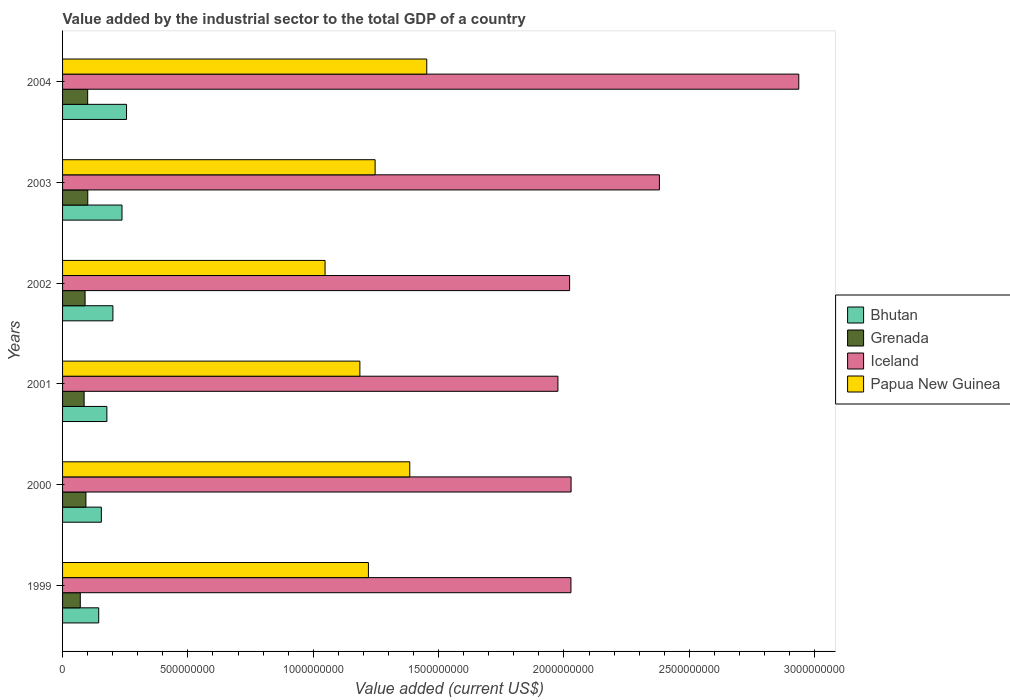How many different coloured bars are there?
Ensure brevity in your answer.  4. Are the number of bars per tick equal to the number of legend labels?
Your answer should be compact. Yes. How many bars are there on the 1st tick from the bottom?
Offer a terse response. 4. In how many cases, is the number of bars for a given year not equal to the number of legend labels?
Your answer should be compact. 0. What is the value added by the industrial sector to the total GDP in Papua New Guinea in 2000?
Keep it short and to the point. 1.38e+09. Across all years, what is the maximum value added by the industrial sector to the total GDP in Papua New Guinea?
Ensure brevity in your answer.  1.45e+09. Across all years, what is the minimum value added by the industrial sector to the total GDP in Iceland?
Provide a succinct answer. 1.98e+09. In which year was the value added by the industrial sector to the total GDP in Papua New Guinea minimum?
Offer a very short reply. 2002. What is the total value added by the industrial sector to the total GDP in Iceland in the graph?
Provide a short and direct response. 1.34e+1. What is the difference between the value added by the industrial sector to the total GDP in Grenada in 1999 and that in 2000?
Keep it short and to the point. -2.25e+07. What is the difference between the value added by the industrial sector to the total GDP in Grenada in 2004 and the value added by the industrial sector to the total GDP in Bhutan in 1999?
Make the answer very short. -4.41e+07. What is the average value added by the industrial sector to the total GDP in Grenada per year?
Provide a succinct answer. 9.00e+07. In the year 2000, what is the difference between the value added by the industrial sector to the total GDP in Grenada and value added by the industrial sector to the total GDP in Bhutan?
Offer a very short reply. -6.15e+07. What is the ratio of the value added by the industrial sector to the total GDP in Grenada in 1999 to that in 2001?
Ensure brevity in your answer.  0.82. Is the value added by the industrial sector to the total GDP in Papua New Guinea in 2001 less than that in 2004?
Keep it short and to the point. Yes. Is the difference between the value added by the industrial sector to the total GDP in Grenada in 2001 and 2003 greater than the difference between the value added by the industrial sector to the total GDP in Bhutan in 2001 and 2003?
Give a very brief answer. Yes. What is the difference between the highest and the second highest value added by the industrial sector to the total GDP in Grenada?
Your answer should be very brief. 4.01e+05. What is the difference between the highest and the lowest value added by the industrial sector to the total GDP in Grenada?
Your answer should be very brief. 2.99e+07. In how many years, is the value added by the industrial sector to the total GDP in Bhutan greater than the average value added by the industrial sector to the total GDP in Bhutan taken over all years?
Your answer should be very brief. 3. Is the sum of the value added by the industrial sector to the total GDP in Bhutan in 2001 and 2004 greater than the maximum value added by the industrial sector to the total GDP in Grenada across all years?
Provide a short and direct response. Yes. What does the 1st bar from the top in 2002 represents?
Your answer should be compact. Papua New Guinea. What does the 1st bar from the bottom in 2001 represents?
Give a very brief answer. Bhutan. How many bars are there?
Your response must be concise. 24. What is the difference between two consecutive major ticks on the X-axis?
Your response must be concise. 5.00e+08. Does the graph contain any zero values?
Provide a succinct answer. No. Where does the legend appear in the graph?
Your response must be concise. Center right. How many legend labels are there?
Offer a very short reply. 4. What is the title of the graph?
Your response must be concise. Value added by the industrial sector to the total GDP of a country. Does "Mauritania" appear as one of the legend labels in the graph?
Keep it short and to the point. No. What is the label or title of the X-axis?
Offer a terse response. Value added (current US$). What is the label or title of the Y-axis?
Keep it short and to the point. Years. What is the Value added (current US$) of Bhutan in 1999?
Keep it short and to the point. 1.44e+08. What is the Value added (current US$) of Grenada in 1999?
Offer a very short reply. 7.06e+07. What is the Value added (current US$) in Iceland in 1999?
Keep it short and to the point. 2.03e+09. What is the Value added (current US$) of Papua New Guinea in 1999?
Your answer should be very brief. 1.22e+09. What is the Value added (current US$) of Bhutan in 2000?
Your answer should be very brief. 1.55e+08. What is the Value added (current US$) of Grenada in 2000?
Your response must be concise. 9.31e+07. What is the Value added (current US$) in Iceland in 2000?
Give a very brief answer. 2.03e+09. What is the Value added (current US$) in Papua New Guinea in 2000?
Provide a short and direct response. 1.38e+09. What is the Value added (current US$) of Bhutan in 2001?
Your answer should be compact. 1.77e+08. What is the Value added (current US$) of Grenada in 2001?
Provide a succinct answer. 8.59e+07. What is the Value added (current US$) in Iceland in 2001?
Give a very brief answer. 1.98e+09. What is the Value added (current US$) in Papua New Guinea in 2001?
Your answer should be very brief. 1.19e+09. What is the Value added (current US$) of Bhutan in 2002?
Provide a succinct answer. 2.01e+08. What is the Value added (current US$) in Grenada in 2002?
Ensure brevity in your answer.  8.98e+07. What is the Value added (current US$) in Iceland in 2002?
Your response must be concise. 2.02e+09. What is the Value added (current US$) in Papua New Guinea in 2002?
Your answer should be compact. 1.05e+09. What is the Value added (current US$) in Bhutan in 2003?
Provide a short and direct response. 2.37e+08. What is the Value added (current US$) of Grenada in 2003?
Provide a succinct answer. 1.01e+08. What is the Value added (current US$) of Iceland in 2003?
Provide a short and direct response. 2.38e+09. What is the Value added (current US$) in Papua New Guinea in 2003?
Offer a terse response. 1.25e+09. What is the Value added (current US$) of Bhutan in 2004?
Provide a short and direct response. 2.55e+08. What is the Value added (current US$) in Grenada in 2004?
Your answer should be compact. 1.00e+08. What is the Value added (current US$) in Iceland in 2004?
Offer a very short reply. 2.94e+09. What is the Value added (current US$) in Papua New Guinea in 2004?
Your response must be concise. 1.45e+09. Across all years, what is the maximum Value added (current US$) in Bhutan?
Offer a very short reply. 2.55e+08. Across all years, what is the maximum Value added (current US$) in Grenada?
Your answer should be compact. 1.01e+08. Across all years, what is the maximum Value added (current US$) in Iceland?
Provide a succinct answer. 2.94e+09. Across all years, what is the maximum Value added (current US$) in Papua New Guinea?
Give a very brief answer. 1.45e+09. Across all years, what is the minimum Value added (current US$) in Bhutan?
Keep it short and to the point. 1.44e+08. Across all years, what is the minimum Value added (current US$) in Grenada?
Your answer should be very brief. 7.06e+07. Across all years, what is the minimum Value added (current US$) of Iceland?
Keep it short and to the point. 1.98e+09. Across all years, what is the minimum Value added (current US$) of Papua New Guinea?
Make the answer very short. 1.05e+09. What is the total Value added (current US$) in Bhutan in the graph?
Offer a terse response. 1.17e+09. What is the total Value added (current US$) in Grenada in the graph?
Provide a succinct answer. 5.40e+08. What is the total Value added (current US$) of Iceland in the graph?
Provide a short and direct response. 1.34e+1. What is the total Value added (current US$) in Papua New Guinea in the graph?
Ensure brevity in your answer.  7.54e+09. What is the difference between the Value added (current US$) of Bhutan in 1999 and that in 2000?
Your response must be concise. -1.04e+07. What is the difference between the Value added (current US$) in Grenada in 1999 and that in 2000?
Your answer should be compact. -2.25e+07. What is the difference between the Value added (current US$) in Iceland in 1999 and that in 2000?
Your response must be concise. -5.31e+05. What is the difference between the Value added (current US$) of Papua New Guinea in 1999 and that in 2000?
Your answer should be very brief. -1.65e+08. What is the difference between the Value added (current US$) of Bhutan in 1999 and that in 2001?
Give a very brief answer. -3.25e+07. What is the difference between the Value added (current US$) in Grenada in 1999 and that in 2001?
Your response must be concise. -1.53e+07. What is the difference between the Value added (current US$) of Iceland in 1999 and that in 2001?
Provide a short and direct response. 5.19e+07. What is the difference between the Value added (current US$) in Papua New Guinea in 1999 and that in 2001?
Keep it short and to the point. 3.41e+07. What is the difference between the Value added (current US$) of Bhutan in 1999 and that in 2002?
Your answer should be compact. -5.66e+07. What is the difference between the Value added (current US$) of Grenada in 1999 and that in 2002?
Offer a very short reply. -1.91e+07. What is the difference between the Value added (current US$) of Iceland in 1999 and that in 2002?
Give a very brief answer. 5.24e+06. What is the difference between the Value added (current US$) of Papua New Guinea in 1999 and that in 2002?
Your answer should be very brief. 1.73e+08. What is the difference between the Value added (current US$) of Bhutan in 1999 and that in 2003?
Your answer should be compact. -9.29e+07. What is the difference between the Value added (current US$) of Grenada in 1999 and that in 2003?
Your answer should be very brief. -2.99e+07. What is the difference between the Value added (current US$) of Iceland in 1999 and that in 2003?
Your response must be concise. -3.53e+08. What is the difference between the Value added (current US$) in Papua New Guinea in 1999 and that in 2003?
Keep it short and to the point. -2.67e+07. What is the difference between the Value added (current US$) of Bhutan in 1999 and that in 2004?
Ensure brevity in your answer.  -1.11e+08. What is the difference between the Value added (current US$) of Grenada in 1999 and that in 2004?
Ensure brevity in your answer.  -2.95e+07. What is the difference between the Value added (current US$) of Iceland in 1999 and that in 2004?
Ensure brevity in your answer.  -9.09e+08. What is the difference between the Value added (current US$) of Papua New Guinea in 1999 and that in 2004?
Keep it short and to the point. -2.33e+08. What is the difference between the Value added (current US$) of Bhutan in 2000 and that in 2001?
Provide a short and direct response. -2.21e+07. What is the difference between the Value added (current US$) of Grenada in 2000 and that in 2001?
Offer a terse response. 7.20e+06. What is the difference between the Value added (current US$) of Iceland in 2000 and that in 2001?
Your response must be concise. 5.24e+07. What is the difference between the Value added (current US$) of Papua New Guinea in 2000 and that in 2001?
Offer a terse response. 1.99e+08. What is the difference between the Value added (current US$) in Bhutan in 2000 and that in 2002?
Provide a short and direct response. -4.62e+07. What is the difference between the Value added (current US$) in Grenada in 2000 and that in 2002?
Provide a succinct answer. 3.35e+06. What is the difference between the Value added (current US$) of Iceland in 2000 and that in 2002?
Keep it short and to the point. 5.77e+06. What is the difference between the Value added (current US$) in Papua New Guinea in 2000 and that in 2002?
Offer a terse response. 3.38e+08. What is the difference between the Value added (current US$) in Bhutan in 2000 and that in 2003?
Provide a short and direct response. -8.24e+07. What is the difference between the Value added (current US$) in Grenada in 2000 and that in 2003?
Offer a very short reply. -7.39e+06. What is the difference between the Value added (current US$) of Iceland in 2000 and that in 2003?
Provide a short and direct response. -3.52e+08. What is the difference between the Value added (current US$) of Papua New Guinea in 2000 and that in 2003?
Offer a terse response. 1.38e+08. What is the difference between the Value added (current US$) in Bhutan in 2000 and that in 2004?
Your answer should be very brief. -1.00e+08. What is the difference between the Value added (current US$) in Grenada in 2000 and that in 2004?
Offer a very short reply. -6.99e+06. What is the difference between the Value added (current US$) of Iceland in 2000 and that in 2004?
Provide a succinct answer. -9.08e+08. What is the difference between the Value added (current US$) in Papua New Guinea in 2000 and that in 2004?
Your answer should be very brief. -6.78e+07. What is the difference between the Value added (current US$) in Bhutan in 2001 and that in 2002?
Your answer should be compact. -2.41e+07. What is the difference between the Value added (current US$) of Grenada in 2001 and that in 2002?
Provide a succinct answer. -3.85e+06. What is the difference between the Value added (current US$) in Iceland in 2001 and that in 2002?
Your answer should be very brief. -4.67e+07. What is the difference between the Value added (current US$) in Papua New Guinea in 2001 and that in 2002?
Keep it short and to the point. 1.39e+08. What is the difference between the Value added (current US$) of Bhutan in 2001 and that in 2003?
Make the answer very short. -6.04e+07. What is the difference between the Value added (current US$) of Grenada in 2001 and that in 2003?
Your response must be concise. -1.46e+07. What is the difference between the Value added (current US$) of Iceland in 2001 and that in 2003?
Your answer should be compact. -4.05e+08. What is the difference between the Value added (current US$) of Papua New Guinea in 2001 and that in 2003?
Give a very brief answer. -6.08e+07. What is the difference between the Value added (current US$) in Bhutan in 2001 and that in 2004?
Give a very brief answer. -7.84e+07. What is the difference between the Value added (current US$) in Grenada in 2001 and that in 2004?
Keep it short and to the point. -1.42e+07. What is the difference between the Value added (current US$) in Iceland in 2001 and that in 2004?
Offer a terse response. -9.61e+08. What is the difference between the Value added (current US$) in Papua New Guinea in 2001 and that in 2004?
Give a very brief answer. -2.67e+08. What is the difference between the Value added (current US$) of Bhutan in 2002 and that in 2003?
Provide a succinct answer. -3.63e+07. What is the difference between the Value added (current US$) in Grenada in 2002 and that in 2003?
Keep it short and to the point. -1.07e+07. What is the difference between the Value added (current US$) of Iceland in 2002 and that in 2003?
Offer a terse response. -3.58e+08. What is the difference between the Value added (current US$) in Papua New Guinea in 2002 and that in 2003?
Provide a succinct answer. -2.00e+08. What is the difference between the Value added (current US$) of Bhutan in 2002 and that in 2004?
Provide a short and direct response. -5.43e+07. What is the difference between the Value added (current US$) in Grenada in 2002 and that in 2004?
Provide a succinct answer. -1.03e+07. What is the difference between the Value added (current US$) in Iceland in 2002 and that in 2004?
Make the answer very short. -9.14e+08. What is the difference between the Value added (current US$) of Papua New Guinea in 2002 and that in 2004?
Offer a terse response. -4.06e+08. What is the difference between the Value added (current US$) in Bhutan in 2003 and that in 2004?
Provide a succinct answer. -1.80e+07. What is the difference between the Value added (current US$) in Grenada in 2003 and that in 2004?
Ensure brevity in your answer.  4.01e+05. What is the difference between the Value added (current US$) of Iceland in 2003 and that in 2004?
Your response must be concise. -5.56e+08. What is the difference between the Value added (current US$) of Papua New Guinea in 2003 and that in 2004?
Offer a terse response. -2.06e+08. What is the difference between the Value added (current US$) in Bhutan in 1999 and the Value added (current US$) in Grenada in 2000?
Offer a terse response. 5.11e+07. What is the difference between the Value added (current US$) in Bhutan in 1999 and the Value added (current US$) in Iceland in 2000?
Your answer should be very brief. -1.88e+09. What is the difference between the Value added (current US$) of Bhutan in 1999 and the Value added (current US$) of Papua New Guinea in 2000?
Make the answer very short. -1.24e+09. What is the difference between the Value added (current US$) of Grenada in 1999 and the Value added (current US$) of Iceland in 2000?
Your response must be concise. -1.96e+09. What is the difference between the Value added (current US$) in Grenada in 1999 and the Value added (current US$) in Papua New Guinea in 2000?
Provide a succinct answer. -1.31e+09. What is the difference between the Value added (current US$) in Iceland in 1999 and the Value added (current US$) in Papua New Guinea in 2000?
Make the answer very short. 6.43e+08. What is the difference between the Value added (current US$) of Bhutan in 1999 and the Value added (current US$) of Grenada in 2001?
Your answer should be compact. 5.83e+07. What is the difference between the Value added (current US$) of Bhutan in 1999 and the Value added (current US$) of Iceland in 2001?
Offer a very short reply. -1.83e+09. What is the difference between the Value added (current US$) in Bhutan in 1999 and the Value added (current US$) in Papua New Guinea in 2001?
Offer a very short reply. -1.04e+09. What is the difference between the Value added (current US$) in Grenada in 1999 and the Value added (current US$) in Iceland in 2001?
Provide a succinct answer. -1.91e+09. What is the difference between the Value added (current US$) of Grenada in 1999 and the Value added (current US$) of Papua New Guinea in 2001?
Give a very brief answer. -1.12e+09. What is the difference between the Value added (current US$) of Iceland in 1999 and the Value added (current US$) of Papua New Guinea in 2001?
Keep it short and to the point. 8.42e+08. What is the difference between the Value added (current US$) in Bhutan in 1999 and the Value added (current US$) in Grenada in 2002?
Give a very brief answer. 5.44e+07. What is the difference between the Value added (current US$) of Bhutan in 1999 and the Value added (current US$) of Iceland in 2002?
Provide a short and direct response. -1.88e+09. What is the difference between the Value added (current US$) in Bhutan in 1999 and the Value added (current US$) in Papua New Guinea in 2002?
Keep it short and to the point. -9.03e+08. What is the difference between the Value added (current US$) in Grenada in 1999 and the Value added (current US$) in Iceland in 2002?
Provide a succinct answer. -1.95e+09. What is the difference between the Value added (current US$) in Grenada in 1999 and the Value added (current US$) in Papua New Guinea in 2002?
Offer a very short reply. -9.76e+08. What is the difference between the Value added (current US$) in Iceland in 1999 and the Value added (current US$) in Papua New Guinea in 2002?
Offer a terse response. 9.81e+08. What is the difference between the Value added (current US$) in Bhutan in 1999 and the Value added (current US$) in Grenada in 2003?
Offer a very short reply. 4.37e+07. What is the difference between the Value added (current US$) in Bhutan in 1999 and the Value added (current US$) in Iceland in 2003?
Provide a succinct answer. -2.24e+09. What is the difference between the Value added (current US$) of Bhutan in 1999 and the Value added (current US$) of Papua New Guinea in 2003?
Make the answer very short. -1.10e+09. What is the difference between the Value added (current US$) of Grenada in 1999 and the Value added (current US$) of Iceland in 2003?
Ensure brevity in your answer.  -2.31e+09. What is the difference between the Value added (current US$) in Grenada in 1999 and the Value added (current US$) in Papua New Guinea in 2003?
Provide a succinct answer. -1.18e+09. What is the difference between the Value added (current US$) of Iceland in 1999 and the Value added (current US$) of Papua New Guinea in 2003?
Make the answer very short. 7.81e+08. What is the difference between the Value added (current US$) in Bhutan in 1999 and the Value added (current US$) in Grenada in 2004?
Your response must be concise. 4.41e+07. What is the difference between the Value added (current US$) in Bhutan in 1999 and the Value added (current US$) in Iceland in 2004?
Keep it short and to the point. -2.79e+09. What is the difference between the Value added (current US$) of Bhutan in 1999 and the Value added (current US$) of Papua New Guinea in 2004?
Offer a terse response. -1.31e+09. What is the difference between the Value added (current US$) of Grenada in 1999 and the Value added (current US$) of Iceland in 2004?
Ensure brevity in your answer.  -2.87e+09. What is the difference between the Value added (current US$) of Grenada in 1999 and the Value added (current US$) of Papua New Guinea in 2004?
Your response must be concise. -1.38e+09. What is the difference between the Value added (current US$) of Iceland in 1999 and the Value added (current US$) of Papua New Guinea in 2004?
Offer a very short reply. 5.75e+08. What is the difference between the Value added (current US$) of Bhutan in 2000 and the Value added (current US$) of Grenada in 2001?
Your answer should be very brief. 6.87e+07. What is the difference between the Value added (current US$) in Bhutan in 2000 and the Value added (current US$) in Iceland in 2001?
Provide a succinct answer. -1.82e+09. What is the difference between the Value added (current US$) of Bhutan in 2000 and the Value added (current US$) of Papua New Guinea in 2001?
Your answer should be very brief. -1.03e+09. What is the difference between the Value added (current US$) in Grenada in 2000 and the Value added (current US$) in Iceland in 2001?
Offer a very short reply. -1.88e+09. What is the difference between the Value added (current US$) in Grenada in 2000 and the Value added (current US$) in Papua New Guinea in 2001?
Your answer should be compact. -1.09e+09. What is the difference between the Value added (current US$) in Iceland in 2000 and the Value added (current US$) in Papua New Guinea in 2001?
Your answer should be very brief. 8.42e+08. What is the difference between the Value added (current US$) in Bhutan in 2000 and the Value added (current US$) in Grenada in 2002?
Make the answer very short. 6.49e+07. What is the difference between the Value added (current US$) in Bhutan in 2000 and the Value added (current US$) in Iceland in 2002?
Offer a terse response. -1.87e+09. What is the difference between the Value added (current US$) of Bhutan in 2000 and the Value added (current US$) of Papua New Guinea in 2002?
Give a very brief answer. -8.92e+08. What is the difference between the Value added (current US$) in Grenada in 2000 and the Value added (current US$) in Iceland in 2002?
Your response must be concise. -1.93e+09. What is the difference between the Value added (current US$) of Grenada in 2000 and the Value added (current US$) of Papua New Guinea in 2002?
Provide a short and direct response. -9.54e+08. What is the difference between the Value added (current US$) in Iceland in 2000 and the Value added (current US$) in Papua New Guinea in 2002?
Your answer should be compact. 9.81e+08. What is the difference between the Value added (current US$) of Bhutan in 2000 and the Value added (current US$) of Grenada in 2003?
Your response must be concise. 5.41e+07. What is the difference between the Value added (current US$) of Bhutan in 2000 and the Value added (current US$) of Iceland in 2003?
Make the answer very short. -2.23e+09. What is the difference between the Value added (current US$) of Bhutan in 2000 and the Value added (current US$) of Papua New Guinea in 2003?
Provide a short and direct response. -1.09e+09. What is the difference between the Value added (current US$) in Grenada in 2000 and the Value added (current US$) in Iceland in 2003?
Offer a very short reply. -2.29e+09. What is the difference between the Value added (current US$) in Grenada in 2000 and the Value added (current US$) in Papua New Guinea in 2003?
Keep it short and to the point. -1.15e+09. What is the difference between the Value added (current US$) in Iceland in 2000 and the Value added (current US$) in Papua New Guinea in 2003?
Your answer should be compact. 7.82e+08. What is the difference between the Value added (current US$) of Bhutan in 2000 and the Value added (current US$) of Grenada in 2004?
Give a very brief answer. 5.45e+07. What is the difference between the Value added (current US$) in Bhutan in 2000 and the Value added (current US$) in Iceland in 2004?
Keep it short and to the point. -2.78e+09. What is the difference between the Value added (current US$) in Bhutan in 2000 and the Value added (current US$) in Papua New Guinea in 2004?
Ensure brevity in your answer.  -1.30e+09. What is the difference between the Value added (current US$) in Grenada in 2000 and the Value added (current US$) in Iceland in 2004?
Provide a succinct answer. -2.84e+09. What is the difference between the Value added (current US$) of Grenada in 2000 and the Value added (current US$) of Papua New Guinea in 2004?
Your answer should be very brief. -1.36e+09. What is the difference between the Value added (current US$) of Iceland in 2000 and the Value added (current US$) of Papua New Guinea in 2004?
Your answer should be compact. 5.76e+08. What is the difference between the Value added (current US$) of Bhutan in 2001 and the Value added (current US$) of Grenada in 2002?
Give a very brief answer. 8.69e+07. What is the difference between the Value added (current US$) of Bhutan in 2001 and the Value added (current US$) of Iceland in 2002?
Keep it short and to the point. -1.85e+09. What is the difference between the Value added (current US$) of Bhutan in 2001 and the Value added (current US$) of Papua New Guinea in 2002?
Your answer should be compact. -8.70e+08. What is the difference between the Value added (current US$) in Grenada in 2001 and the Value added (current US$) in Iceland in 2002?
Offer a very short reply. -1.94e+09. What is the difference between the Value added (current US$) of Grenada in 2001 and the Value added (current US$) of Papua New Guinea in 2002?
Give a very brief answer. -9.61e+08. What is the difference between the Value added (current US$) in Iceland in 2001 and the Value added (current US$) in Papua New Guinea in 2002?
Provide a succinct answer. 9.29e+08. What is the difference between the Value added (current US$) of Bhutan in 2001 and the Value added (current US$) of Grenada in 2003?
Provide a short and direct response. 7.62e+07. What is the difference between the Value added (current US$) of Bhutan in 2001 and the Value added (current US$) of Iceland in 2003?
Provide a succinct answer. -2.20e+09. What is the difference between the Value added (current US$) of Bhutan in 2001 and the Value added (current US$) of Papua New Guinea in 2003?
Offer a terse response. -1.07e+09. What is the difference between the Value added (current US$) of Grenada in 2001 and the Value added (current US$) of Iceland in 2003?
Your answer should be very brief. -2.29e+09. What is the difference between the Value added (current US$) of Grenada in 2001 and the Value added (current US$) of Papua New Guinea in 2003?
Make the answer very short. -1.16e+09. What is the difference between the Value added (current US$) of Iceland in 2001 and the Value added (current US$) of Papua New Guinea in 2003?
Provide a succinct answer. 7.29e+08. What is the difference between the Value added (current US$) in Bhutan in 2001 and the Value added (current US$) in Grenada in 2004?
Keep it short and to the point. 7.66e+07. What is the difference between the Value added (current US$) in Bhutan in 2001 and the Value added (current US$) in Iceland in 2004?
Offer a very short reply. -2.76e+09. What is the difference between the Value added (current US$) of Bhutan in 2001 and the Value added (current US$) of Papua New Guinea in 2004?
Offer a very short reply. -1.28e+09. What is the difference between the Value added (current US$) in Grenada in 2001 and the Value added (current US$) in Iceland in 2004?
Keep it short and to the point. -2.85e+09. What is the difference between the Value added (current US$) in Grenada in 2001 and the Value added (current US$) in Papua New Guinea in 2004?
Your response must be concise. -1.37e+09. What is the difference between the Value added (current US$) of Iceland in 2001 and the Value added (current US$) of Papua New Guinea in 2004?
Offer a very short reply. 5.23e+08. What is the difference between the Value added (current US$) of Bhutan in 2002 and the Value added (current US$) of Grenada in 2003?
Provide a succinct answer. 1.00e+08. What is the difference between the Value added (current US$) of Bhutan in 2002 and the Value added (current US$) of Iceland in 2003?
Provide a short and direct response. -2.18e+09. What is the difference between the Value added (current US$) in Bhutan in 2002 and the Value added (current US$) in Papua New Guinea in 2003?
Ensure brevity in your answer.  -1.05e+09. What is the difference between the Value added (current US$) in Grenada in 2002 and the Value added (current US$) in Iceland in 2003?
Provide a short and direct response. -2.29e+09. What is the difference between the Value added (current US$) of Grenada in 2002 and the Value added (current US$) of Papua New Guinea in 2003?
Offer a terse response. -1.16e+09. What is the difference between the Value added (current US$) in Iceland in 2002 and the Value added (current US$) in Papua New Guinea in 2003?
Give a very brief answer. 7.76e+08. What is the difference between the Value added (current US$) of Bhutan in 2002 and the Value added (current US$) of Grenada in 2004?
Your answer should be compact. 1.01e+08. What is the difference between the Value added (current US$) of Bhutan in 2002 and the Value added (current US$) of Iceland in 2004?
Your response must be concise. -2.74e+09. What is the difference between the Value added (current US$) in Bhutan in 2002 and the Value added (current US$) in Papua New Guinea in 2004?
Ensure brevity in your answer.  -1.25e+09. What is the difference between the Value added (current US$) in Grenada in 2002 and the Value added (current US$) in Iceland in 2004?
Your answer should be very brief. -2.85e+09. What is the difference between the Value added (current US$) of Grenada in 2002 and the Value added (current US$) of Papua New Guinea in 2004?
Keep it short and to the point. -1.36e+09. What is the difference between the Value added (current US$) in Iceland in 2002 and the Value added (current US$) in Papua New Guinea in 2004?
Offer a very short reply. 5.70e+08. What is the difference between the Value added (current US$) in Bhutan in 2003 and the Value added (current US$) in Grenada in 2004?
Your answer should be compact. 1.37e+08. What is the difference between the Value added (current US$) in Bhutan in 2003 and the Value added (current US$) in Iceland in 2004?
Offer a terse response. -2.70e+09. What is the difference between the Value added (current US$) of Bhutan in 2003 and the Value added (current US$) of Papua New Guinea in 2004?
Provide a succinct answer. -1.22e+09. What is the difference between the Value added (current US$) of Grenada in 2003 and the Value added (current US$) of Iceland in 2004?
Your response must be concise. -2.84e+09. What is the difference between the Value added (current US$) of Grenada in 2003 and the Value added (current US$) of Papua New Guinea in 2004?
Your answer should be compact. -1.35e+09. What is the difference between the Value added (current US$) in Iceland in 2003 and the Value added (current US$) in Papua New Guinea in 2004?
Ensure brevity in your answer.  9.28e+08. What is the average Value added (current US$) of Bhutan per year?
Your response must be concise. 1.95e+08. What is the average Value added (current US$) of Grenada per year?
Make the answer very short. 9.00e+07. What is the average Value added (current US$) of Iceland per year?
Your answer should be compact. 2.23e+09. What is the average Value added (current US$) in Papua New Guinea per year?
Make the answer very short. 1.26e+09. In the year 1999, what is the difference between the Value added (current US$) of Bhutan and Value added (current US$) of Grenada?
Your answer should be very brief. 7.36e+07. In the year 1999, what is the difference between the Value added (current US$) in Bhutan and Value added (current US$) in Iceland?
Keep it short and to the point. -1.88e+09. In the year 1999, what is the difference between the Value added (current US$) of Bhutan and Value added (current US$) of Papua New Guinea?
Provide a succinct answer. -1.08e+09. In the year 1999, what is the difference between the Value added (current US$) in Grenada and Value added (current US$) in Iceland?
Give a very brief answer. -1.96e+09. In the year 1999, what is the difference between the Value added (current US$) of Grenada and Value added (current US$) of Papua New Guinea?
Provide a short and direct response. -1.15e+09. In the year 1999, what is the difference between the Value added (current US$) of Iceland and Value added (current US$) of Papua New Guinea?
Provide a short and direct response. 8.08e+08. In the year 2000, what is the difference between the Value added (current US$) in Bhutan and Value added (current US$) in Grenada?
Ensure brevity in your answer.  6.15e+07. In the year 2000, what is the difference between the Value added (current US$) of Bhutan and Value added (current US$) of Iceland?
Your response must be concise. -1.87e+09. In the year 2000, what is the difference between the Value added (current US$) in Bhutan and Value added (current US$) in Papua New Guinea?
Give a very brief answer. -1.23e+09. In the year 2000, what is the difference between the Value added (current US$) of Grenada and Value added (current US$) of Iceland?
Offer a terse response. -1.94e+09. In the year 2000, what is the difference between the Value added (current US$) of Grenada and Value added (current US$) of Papua New Guinea?
Offer a very short reply. -1.29e+09. In the year 2000, what is the difference between the Value added (current US$) of Iceland and Value added (current US$) of Papua New Guinea?
Make the answer very short. 6.43e+08. In the year 2001, what is the difference between the Value added (current US$) of Bhutan and Value added (current US$) of Grenada?
Your answer should be very brief. 9.08e+07. In the year 2001, what is the difference between the Value added (current US$) of Bhutan and Value added (current US$) of Iceland?
Offer a terse response. -1.80e+09. In the year 2001, what is the difference between the Value added (current US$) in Bhutan and Value added (current US$) in Papua New Guinea?
Offer a very short reply. -1.01e+09. In the year 2001, what is the difference between the Value added (current US$) in Grenada and Value added (current US$) in Iceland?
Keep it short and to the point. -1.89e+09. In the year 2001, what is the difference between the Value added (current US$) in Grenada and Value added (current US$) in Papua New Guinea?
Provide a short and direct response. -1.10e+09. In the year 2001, what is the difference between the Value added (current US$) of Iceland and Value added (current US$) of Papua New Guinea?
Your response must be concise. 7.90e+08. In the year 2002, what is the difference between the Value added (current US$) of Bhutan and Value added (current US$) of Grenada?
Offer a very short reply. 1.11e+08. In the year 2002, what is the difference between the Value added (current US$) in Bhutan and Value added (current US$) in Iceland?
Give a very brief answer. -1.82e+09. In the year 2002, what is the difference between the Value added (current US$) in Bhutan and Value added (current US$) in Papua New Guinea?
Provide a short and direct response. -8.46e+08. In the year 2002, what is the difference between the Value added (current US$) in Grenada and Value added (current US$) in Iceland?
Provide a short and direct response. -1.93e+09. In the year 2002, what is the difference between the Value added (current US$) in Grenada and Value added (current US$) in Papua New Guinea?
Provide a short and direct response. -9.57e+08. In the year 2002, what is the difference between the Value added (current US$) of Iceland and Value added (current US$) of Papua New Guinea?
Give a very brief answer. 9.76e+08. In the year 2003, what is the difference between the Value added (current US$) of Bhutan and Value added (current US$) of Grenada?
Offer a terse response. 1.37e+08. In the year 2003, what is the difference between the Value added (current US$) of Bhutan and Value added (current US$) of Iceland?
Your answer should be very brief. -2.14e+09. In the year 2003, what is the difference between the Value added (current US$) of Bhutan and Value added (current US$) of Papua New Guinea?
Provide a short and direct response. -1.01e+09. In the year 2003, what is the difference between the Value added (current US$) in Grenada and Value added (current US$) in Iceland?
Your answer should be compact. -2.28e+09. In the year 2003, what is the difference between the Value added (current US$) of Grenada and Value added (current US$) of Papua New Guinea?
Your response must be concise. -1.15e+09. In the year 2003, what is the difference between the Value added (current US$) in Iceland and Value added (current US$) in Papua New Guinea?
Provide a short and direct response. 1.13e+09. In the year 2004, what is the difference between the Value added (current US$) of Bhutan and Value added (current US$) of Grenada?
Your answer should be compact. 1.55e+08. In the year 2004, what is the difference between the Value added (current US$) in Bhutan and Value added (current US$) in Iceland?
Offer a very short reply. -2.68e+09. In the year 2004, what is the difference between the Value added (current US$) in Bhutan and Value added (current US$) in Papua New Guinea?
Your response must be concise. -1.20e+09. In the year 2004, what is the difference between the Value added (current US$) of Grenada and Value added (current US$) of Iceland?
Keep it short and to the point. -2.84e+09. In the year 2004, what is the difference between the Value added (current US$) of Grenada and Value added (current US$) of Papua New Guinea?
Ensure brevity in your answer.  -1.35e+09. In the year 2004, what is the difference between the Value added (current US$) in Iceland and Value added (current US$) in Papua New Guinea?
Your answer should be compact. 1.48e+09. What is the ratio of the Value added (current US$) of Bhutan in 1999 to that in 2000?
Give a very brief answer. 0.93. What is the ratio of the Value added (current US$) of Grenada in 1999 to that in 2000?
Keep it short and to the point. 0.76. What is the ratio of the Value added (current US$) in Iceland in 1999 to that in 2000?
Ensure brevity in your answer.  1. What is the ratio of the Value added (current US$) of Papua New Guinea in 1999 to that in 2000?
Your response must be concise. 0.88. What is the ratio of the Value added (current US$) of Bhutan in 1999 to that in 2001?
Provide a succinct answer. 0.82. What is the ratio of the Value added (current US$) in Grenada in 1999 to that in 2001?
Make the answer very short. 0.82. What is the ratio of the Value added (current US$) in Iceland in 1999 to that in 2001?
Offer a very short reply. 1.03. What is the ratio of the Value added (current US$) in Papua New Guinea in 1999 to that in 2001?
Keep it short and to the point. 1.03. What is the ratio of the Value added (current US$) in Bhutan in 1999 to that in 2002?
Make the answer very short. 0.72. What is the ratio of the Value added (current US$) in Grenada in 1999 to that in 2002?
Your answer should be compact. 0.79. What is the ratio of the Value added (current US$) of Papua New Guinea in 1999 to that in 2002?
Offer a very short reply. 1.17. What is the ratio of the Value added (current US$) in Bhutan in 1999 to that in 2003?
Ensure brevity in your answer.  0.61. What is the ratio of the Value added (current US$) of Grenada in 1999 to that in 2003?
Offer a terse response. 0.7. What is the ratio of the Value added (current US$) of Iceland in 1999 to that in 2003?
Your answer should be very brief. 0.85. What is the ratio of the Value added (current US$) of Papua New Guinea in 1999 to that in 2003?
Offer a terse response. 0.98. What is the ratio of the Value added (current US$) of Bhutan in 1999 to that in 2004?
Make the answer very short. 0.57. What is the ratio of the Value added (current US$) of Grenada in 1999 to that in 2004?
Provide a succinct answer. 0.71. What is the ratio of the Value added (current US$) in Iceland in 1999 to that in 2004?
Provide a succinct answer. 0.69. What is the ratio of the Value added (current US$) in Papua New Guinea in 1999 to that in 2004?
Offer a terse response. 0.84. What is the ratio of the Value added (current US$) of Bhutan in 2000 to that in 2001?
Ensure brevity in your answer.  0.88. What is the ratio of the Value added (current US$) in Grenada in 2000 to that in 2001?
Your answer should be very brief. 1.08. What is the ratio of the Value added (current US$) in Iceland in 2000 to that in 2001?
Offer a terse response. 1.03. What is the ratio of the Value added (current US$) of Papua New Guinea in 2000 to that in 2001?
Your answer should be very brief. 1.17. What is the ratio of the Value added (current US$) of Bhutan in 2000 to that in 2002?
Offer a terse response. 0.77. What is the ratio of the Value added (current US$) of Grenada in 2000 to that in 2002?
Make the answer very short. 1.04. What is the ratio of the Value added (current US$) of Iceland in 2000 to that in 2002?
Offer a terse response. 1. What is the ratio of the Value added (current US$) in Papua New Guinea in 2000 to that in 2002?
Offer a terse response. 1.32. What is the ratio of the Value added (current US$) in Bhutan in 2000 to that in 2003?
Provide a short and direct response. 0.65. What is the ratio of the Value added (current US$) of Grenada in 2000 to that in 2003?
Your answer should be compact. 0.93. What is the ratio of the Value added (current US$) in Iceland in 2000 to that in 2003?
Your response must be concise. 0.85. What is the ratio of the Value added (current US$) in Papua New Guinea in 2000 to that in 2003?
Keep it short and to the point. 1.11. What is the ratio of the Value added (current US$) of Bhutan in 2000 to that in 2004?
Your answer should be very brief. 0.61. What is the ratio of the Value added (current US$) in Grenada in 2000 to that in 2004?
Your answer should be very brief. 0.93. What is the ratio of the Value added (current US$) of Iceland in 2000 to that in 2004?
Your answer should be very brief. 0.69. What is the ratio of the Value added (current US$) in Papua New Guinea in 2000 to that in 2004?
Your response must be concise. 0.95. What is the ratio of the Value added (current US$) of Bhutan in 2001 to that in 2002?
Your answer should be very brief. 0.88. What is the ratio of the Value added (current US$) in Grenada in 2001 to that in 2002?
Keep it short and to the point. 0.96. What is the ratio of the Value added (current US$) in Iceland in 2001 to that in 2002?
Give a very brief answer. 0.98. What is the ratio of the Value added (current US$) in Papua New Guinea in 2001 to that in 2002?
Provide a succinct answer. 1.13. What is the ratio of the Value added (current US$) of Bhutan in 2001 to that in 2003?
Provide a succinct answer. 0.75. What is the ratio of the Value added (current US$) of Grenada in 2001 to that in 2003?
Offer a very short reply. 0.85. What is the ratio of the Value added (current US$) of Iceland in 2001 to that in 2003?
Your answer should be very brief. 0.83. What is the ratio of the Value added (current US$) in Papua New Guinea in 2001 to that in 2003?
Provide a short and direct response. 0.95. What is the ratio of the Value added (current US$) in Bhutan in 2001 to that in 2004?
Make the answer very short. 0.69. What is the ratio of the Value added (current US$) of Grenada in 2001 to that in 2004?
Your answer should be very brief. 0.86. What is the ratio of the Value added (current US$) in Iceland in 2001 to that in 2004?
Give a very brief answer. 0.67. What is the ratio of the Value added (current US$) of Papua New Guinea in 2001 to that in 2004?
Your answer should be very brief. 0.82. What is the ratio of the Value added (current US$) of Bhutan in 2002 to that in 2003?
Offer a very short reply. 0.85. What is the ratio of the Value added (current US$) in Grenada in 2002 to that in 2003?
Keep it short and to the point. 0.89. What is the ratio of the Value added (current US$) of Iceland in 2002 to that in 2003?
Provide a succinct answer. 0.85. What is the ratio of the Value added (current US$) of Papua New Guinea in 2002 to that in 2003?
Provide a short and direct response. 0.84. What is the ratio of the Value added (current US$) in Bhutan in 2002 to that in 2004?
Offer a terse response. 0.79. What is the ratio of the Value added (current US$) of Grenada in 2002 to that in 2004?
Your response must be concise. 0.9. What is the ratio of the Value added (current US$) in Iceland in 2002 to that in 2004?
Your response must be concise. 0.69. What is the ratio of the Value added (current US$) of Papua New Guinea in 2002 to that in 2004?
Provide a succinct answer. 0.72. What is the ratio of the Value added (current US$) in Bhutan in 2003 to that in 2004?
Your response must be concise. 0.93. What is the ratio of the Value added (current US$) of Grenada in 2003 to that in 2004?
Your answer should be compact. 1. What is the ratio of the Value added (current US$) of Iceland in 2003 to that in 2004?
Ensure brevity in your answer.  0.81. What is the ratio of the Value added (current US$) of Papua New Guinea in 2003 to that in 2004?
Keep it short and to the point. 0.86. What is the difference between the highest and the second highest Value added (current US$) of Bhutan?
Make the answer very short. 1.80e+07. What is the difference between the highest and the second highest Value added (current US$) in Grenada?
Your answer should be compact. 4.01e+05. What is the difference between the highest and the second highest Value added (current US$) in Iceland?
Keep it short and to the point. 5.56e+08. What is the difference between the highest and the second highest Value added (current US$) in Papua New Guinea?
Your response must be concise. 6.78e+07. What is the difference between the highest and the lowest Value added (current US$) in Bhutan?
Provide a short and direct response. 1.11e+08. What is the difference between the highest and the lowest Value added (current US$) of Grenada?
Give a very brief answer. 2.99e+07. What is the difference between the highest and the lowest Value added (current US$) in Iceland?
Provide a succinct answer. 9.61e+08. What is the difference between the highest and the lowest Value added (current US$) in Papua New Guinea?
Your response must be concise. 4.06e+08. 